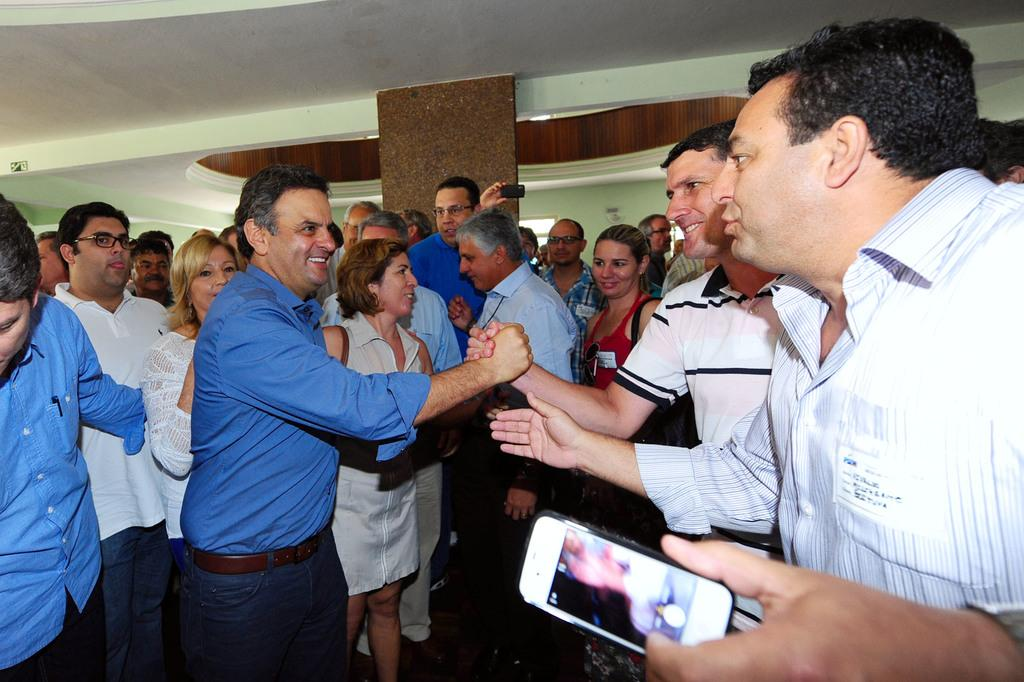What is happening in the image involving the group of people? The people in the image are appreciating each other. Can you describe the man on the right side of the image? The man on the right side of the image is holding a mobile phone in his hand. What is the overall mood or atmosphere in the image? The overall mood or atmosphere in the image is one of appreciation and camaraderie. What type of wood is being used to make the payment in the image? There is no payment or wood present in the image; it features a group of people appreciating each other and a man holding a mobile phone. 